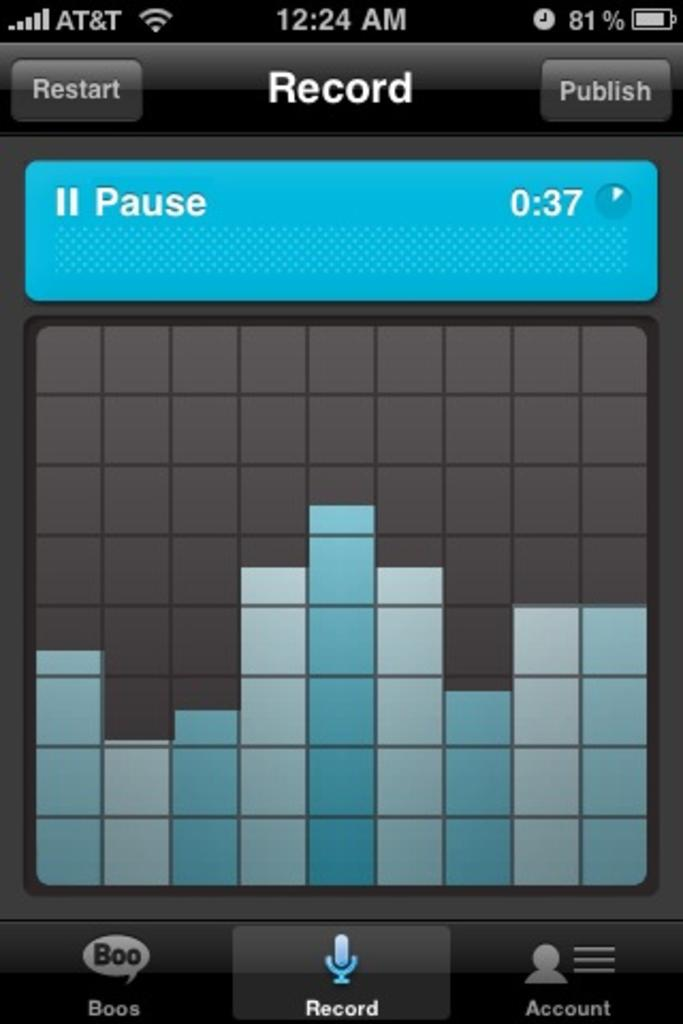<image>
Create a compact narrative representing the image presented. An AT&T cell phone has an app open that says Record. 